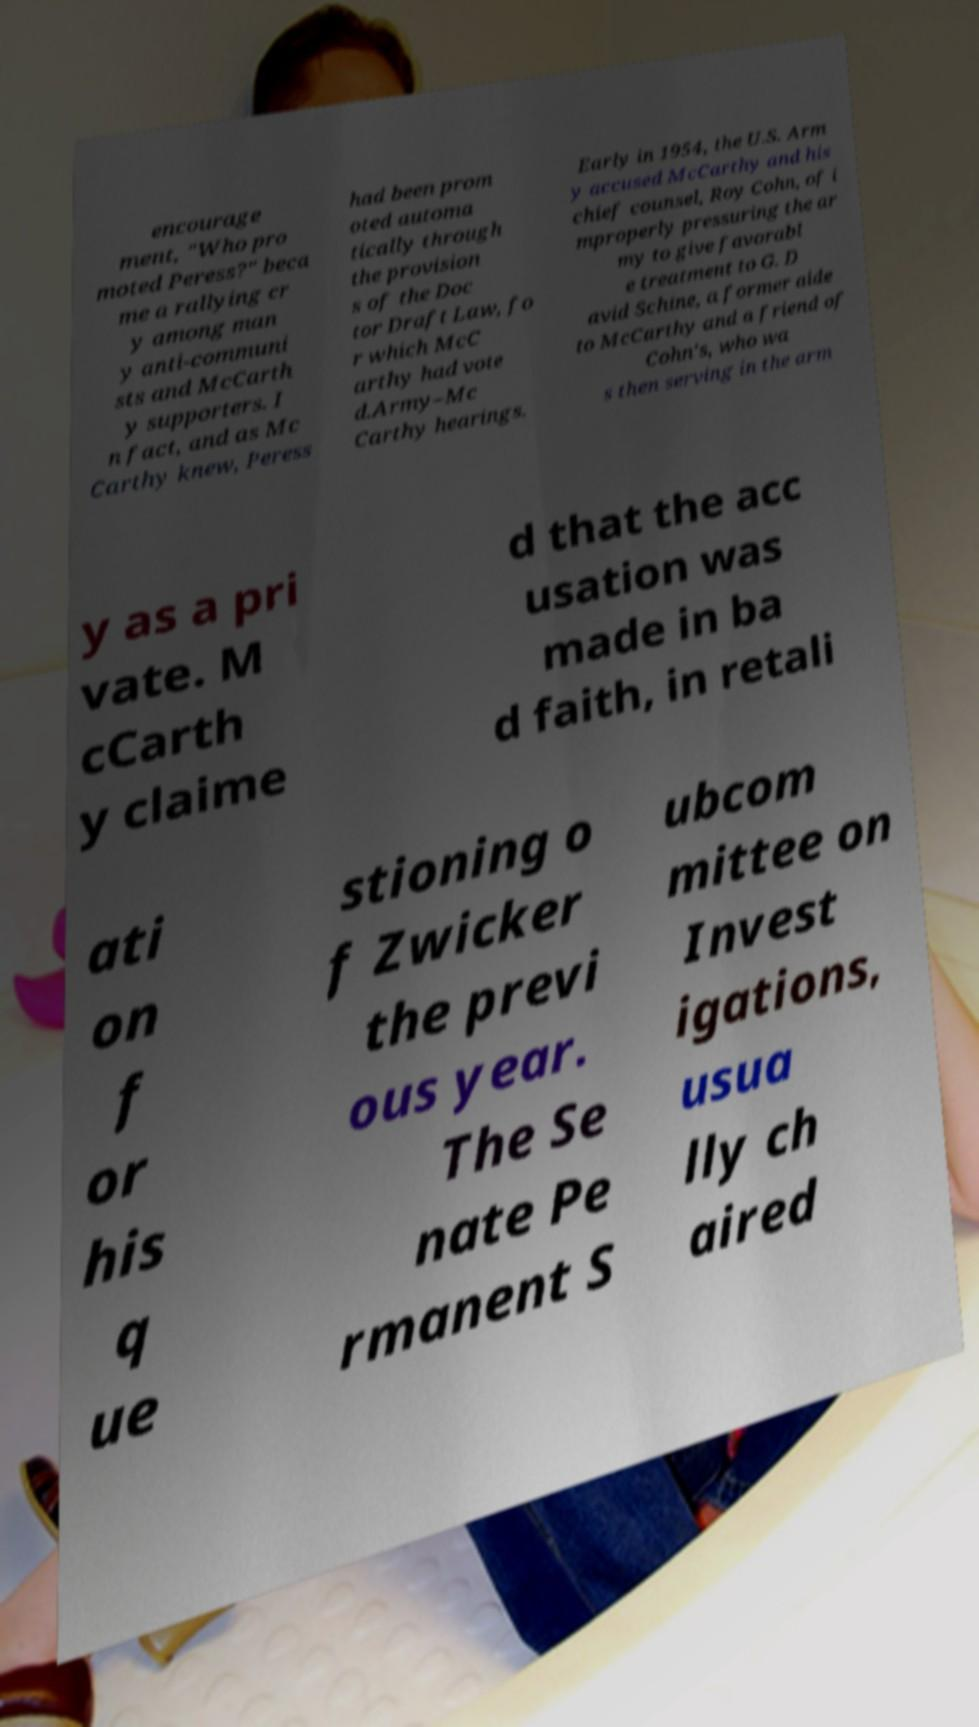For documentation purposes, I need the text within this image transcribed. Could you provide that? encourage ment, "Who pro moted Peress?" beca me a rallying cr y among man y anti-communi sts and McCarth y supporters. I n fact, and as Mc Carthy knew, Peress had been prom oted automa tically through the provision s of the Doc tor Draft Law, fo r which McC arthy had vote d.Army–Mc Carthy hearings. Early in 1954, the U.S. Arm y accused McCarthy and his chief counsel, Roy Cohn, of i mproperly pressuring the ar my to give favorabl e treatment to G. D avid Schine, a former aide to McCarthy and a friend of Cohn's, who wa s then serving in the arm y as a pri vate. M cCarth y claime d that the acc usation was made in ba d faith, in retali ati on f or his q ue stioning o f Zwicker the previ ous year. The Se nate Pe rmanent S ubcom mittee on Invest igations, usua lly ch aired 